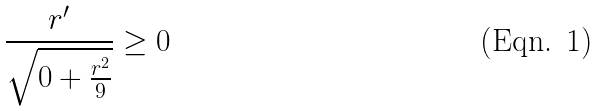Convert formula to latex. <formula><loc_0><loc_0><loc_500><loc_500>\frac { r ^ { \prime } } { \sqrt { 0 + \frac { r ^ { 2 } } { 9 } } } \geq 0</formula> 